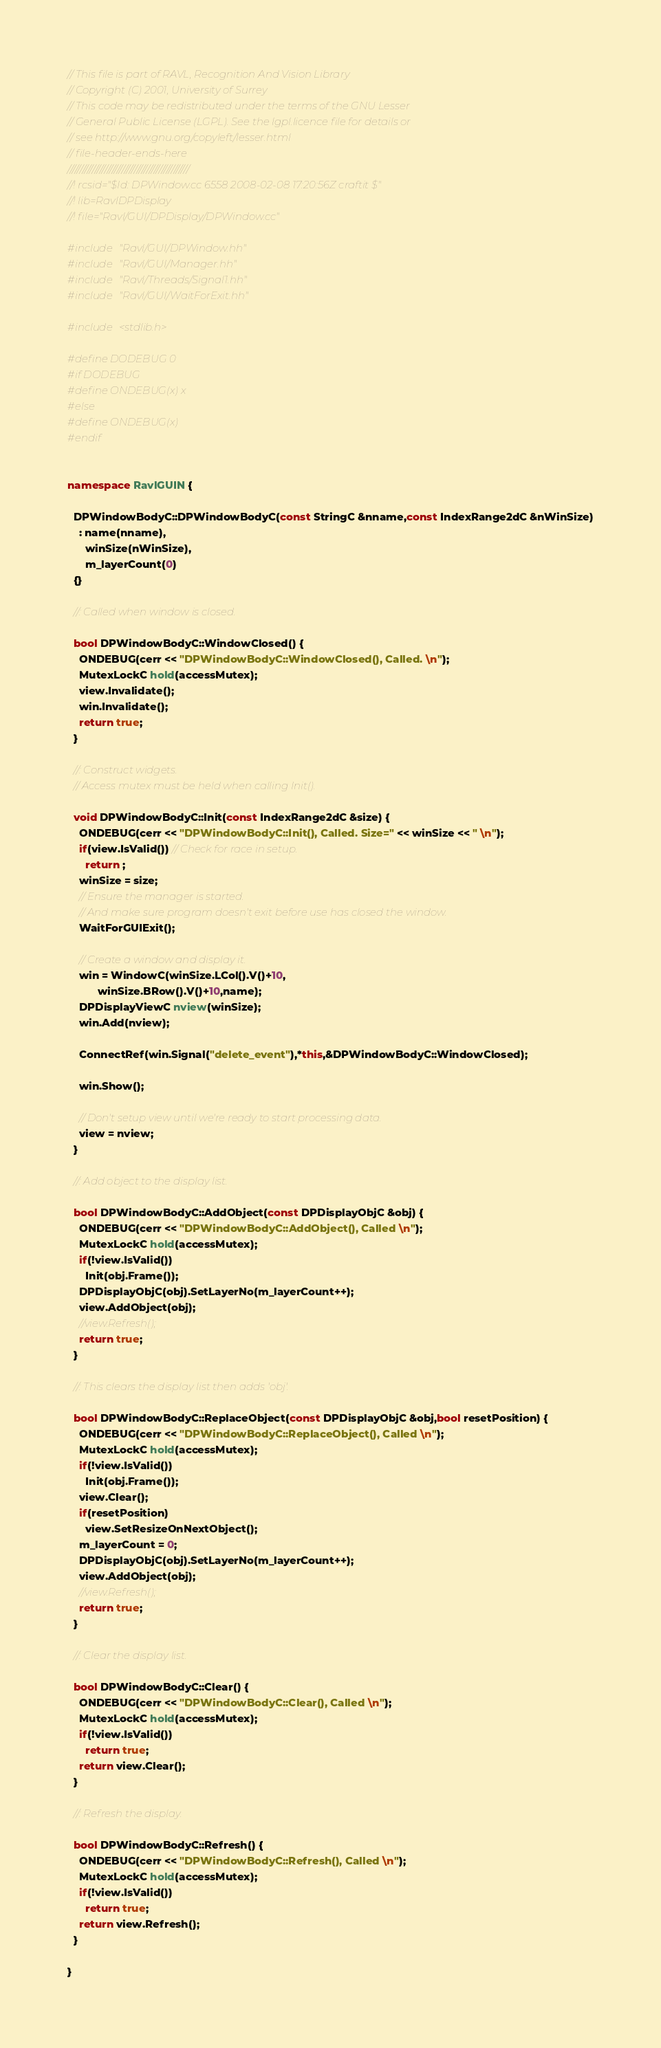<code> <loc_0><loc_0><loc_500><loc_500><_C++_>// This file is part of RAVL, Recognition And Vision Library 
// Copyright (C) 2001, University of Surrey
// This code may be redistributed under the terms of the GNU Lesser
// General Public License (LGPL). See the lgpl.licence file for details or
// see http://www.gnu.org/copyleft/lesser.html
// file-header-ends-here
/////////////////////////////////////////////////
//! rcsid="$Id: DPWindow.cc 6558 2008-02-08 17:20:56Z craftit $"
//! lib=RavlDPDisplay
//! file="Ravl/GUI/DPDisplay/DPWindow.cc"

#include "Ravl/GUI/DPWindow.hh"
#include "Ravl/GUI/Manager.hh"
#include "Ravl/Threads/Signal1.hh"
#include "Ravl/GUI/WaitForExit.hh"

#include <stdlib.h>

#define DODEBUG 0
#if DODEBUG
#define ONDEBUG(x) x
#else
#define ONDEBUG(x)
#endif


namespace RavlGUIN {
  
  DPWindowBodyC::DPWindowBodyC(const StringC &nname,const IndexRange2dC &nWinSize)
    : name(nname),
      winSize(nWinSize),
      m_layerCount(0)
  {}
  
  //: Called when window is closed.
  
  bool DPWindowBodyC::WindowClosed() {
    ONDEBUG(cerr << "DPWindowBodyC::WindowClosed(), Called. \n");
    MutexLockC hold(accessMutex);
    view.Invalidate();
    win.Invalidate();
    return true;
  }
  
  //: Construct widgets.
  // Access mutex must be held when calling Init().
  
  void DPWindowBodyC::Init(const IndexRange2dC &size) {
    ONDEBUG(cerr << "DPWindowBodyC::Init(), Called. Size=" << winSize << " \n");
    if(view.IsValid()) // Check for race in setup.
      return ;
    winSize = size;
    // Ensure the manager is started.
    // And make sure program doesn't exit before use has closed the window.
    WaitForGUIExit(); 
    
    // Create a window and display it.
    win = WindowC(winSize.LCol().V()+10,
		  winSize.BRow().V()+10,name);
    DPDisplayViewC nview(winSize);
    win.Add(nview);
    
    ConnectRef(win.Signal("delete_event"),*this,&DPWindowBodyC::WindowClosed);
    
    win.Show();
    
    // Don't setup view until we're ready to start processing data.
    view = nview;
  }
  
  //: Add object to the display list.
  
  bool DPWindowBodyC::AddObject(const DPDisplayObjC &obj) { 
    ONDEBUG(cerr << "DPWindowBodyC::AddObject(), Called \n");
    MutexLockC hold(accessMutex);
    if(!view.IsValid()) 
      Init(obj.Frame());
    DPDisplayObjC(obj).SetLayerNo(m_layerCount++);
    view.AddObject(obj);
    //view.Refresh();
    return true;
  }
  
  //: This clears the display list then adds 'obj'.
  
  bool DPWindowBodyC::ReplaceObject(const DPDisplayObjC &obj,bool resetPosition) {
    ONDEBUG(cerr << "DPWindowBodyC::ReplaceObject(), Called \n");
    MutexLockC hold(accessMutex);
    if(!view.IsValid()) 
      Init(obj.Frame());
    view.Clear();
    if(resetPosition)
      view.SetResizeOnNextObject();
    m_layerCount = 0;
    DPDisplayObjC(obj).SetLayerNo(m_layerCount++);
    view.AddObject(obj);
    //view.Refresh();
    return true;
  }
  
  //: Clear the display list.
  
  bool DPWindowBodyC::Clear() {  
    ONDEBUG(cerr << "DPWindowBodyC::Clear(), Called \n");
    MutexLockC hold(accessMutex);
    if(!view.IsValid())
      return true;
    return view.Clear();
  }
  
  //: Refresh the display.
  
  bool DPWindowBodyC::Refresh() {
    ONDEBUG(cerr << "DPWindowBodyC::Refresh(), Called \n");
    MutexLockC hold(accessMutex);
    if(!view.IsValid())
      return true;
    return view.Refresh();
  }

}
</code> 